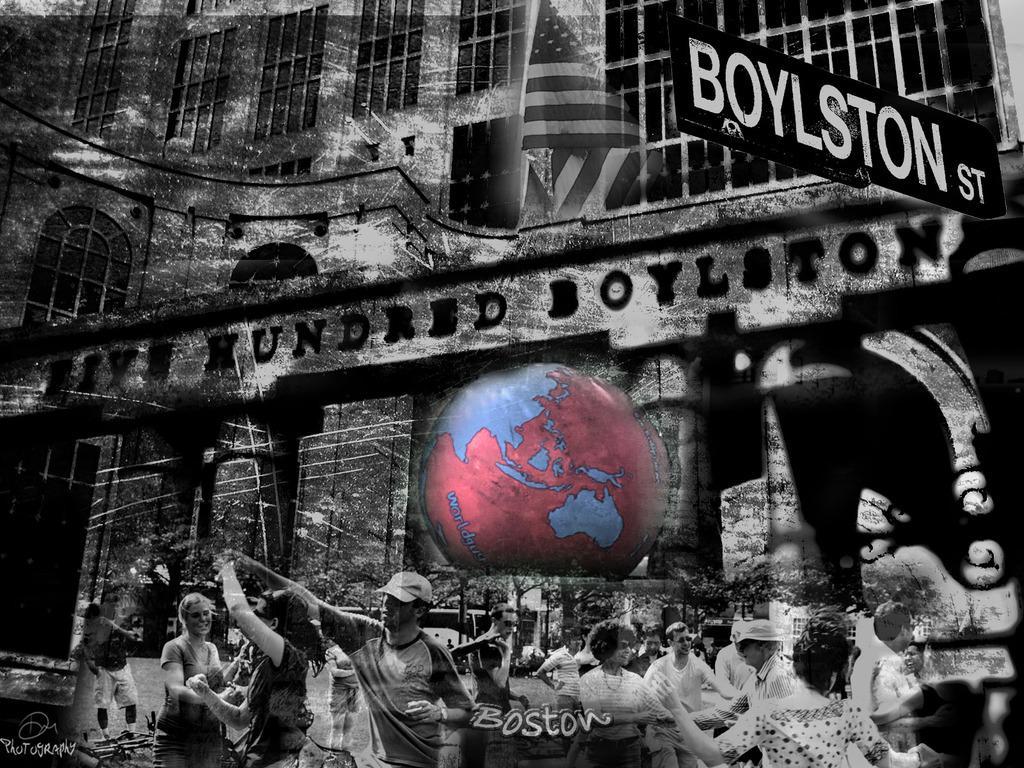Could you give a brief overview of what you see in this image? In this picture we can see a globe and a flag. There is a building. We can see few arches on this building. A direction sign board is visible on top right. A watermark is seen on bottom left. Few people are visible on the path. 